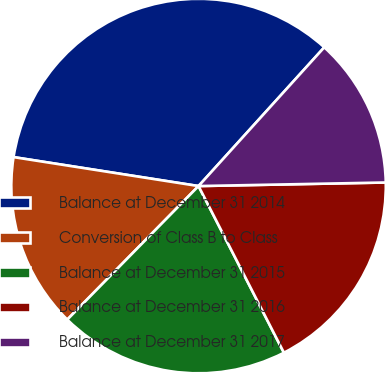Convert chart. <chart><loc_0><loc_0><loc_500><loc_500><pie_chart><fcel>Balance at December 31 2014<fcel>Conversion of Class B to Class<fcel>Balance at December 31 2015<fcel>Balance at December 31 2016<fcel>Balance at December 31 2017<nl><fcel>34.25%<fcel>15.11%<fcel>19.9%<fcel>17.77%<fcel>12.98%<nl></chart> 